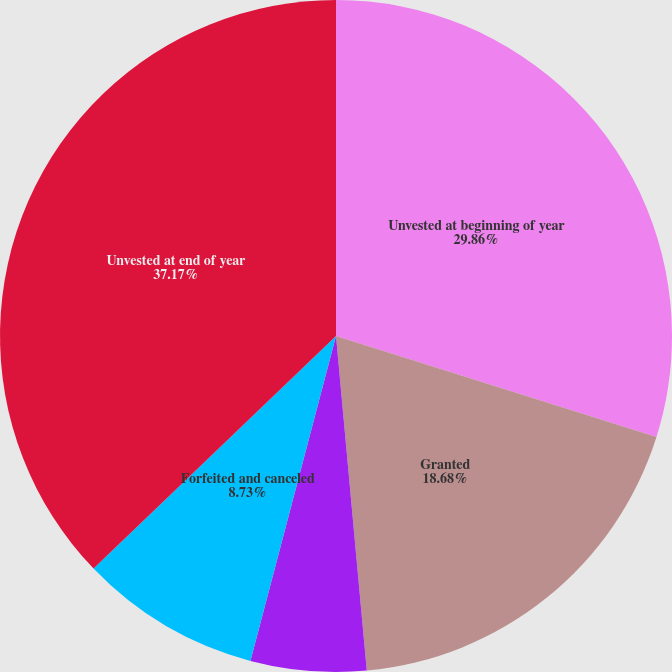Convert chart. <chart><loc_0><loc_0><loc_500><loc_500><pie_chart><fcel>Unvested at beginning of year<fcel>Granted<fcel>Vested<fcel>Forfeited and canceled<fcel>Unvested at end of year<nl><fcel>29.86%<fcel>18.68%<fcel>5.56%<fcel>8.73%<fcel>37.17%<nl></chart> 